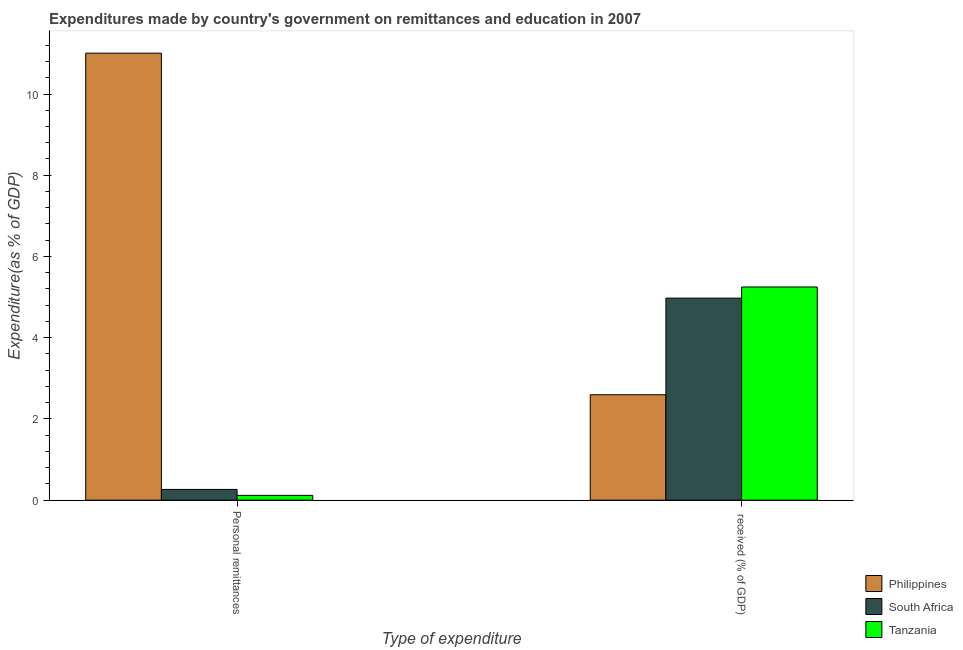How many bars are there on the 1st tick from the left?
Make the answer very short. 3. How many bars are there on the 1st tick from the right?
Offer a terse response. 3. What is the label of the 2nd group of bars from the left?
Give a very brief answer.  received (% of GDP). What is the expenditure in personal remittances in Tanzania?
Offer a very short reply. 0.12. Across all countries, what is the maximum expenditure in education?
Offer a terse response. 5.25. Across all countries, what is the minimum expenditure in education?
Provide a succinct answer. 2.6. In which country was the expenditure in personal remittances minimum?
Keep it short and to the point. Tanzania. What is the total expenditure in education in the graph?
Your answer should be compact. 12.82. What is the difference between the expenditure in personal remittances in Philippines and that in Tanzania?
Your response must be concise. 10.89. What is the difference between the expenditure in personal remittances in Philippines and the expenditure in education in South Africa?
Your answer should be compact. 6.03. What is the average expenditure in personal remittances per country?
Give a very brief answer. 3.8. What is the difference between the expenditure in education and expenditure in personal remittances in Tanzania?
Give a very brief answer. 5.13. In how many countries, is the expenditure in personal remittances greater than 1.6 %?
Make the answer very short. 1. What is the ratio of the expenditure in education in Philippines to that in South Africa?
Offer a very short reply. 0.52. In how many countries, is the expenditure in education greater than the average expenditure in education taken over all countries?
Give a very brief answer. 2. What does the 3rd bar from the left in  received (% of GDP) represents?
Make the answer very short. Tanzania. What does the 2nd bar from the right in  received (% of GDP) represents?
Give a very brief answer. South Africa. Are all the bars in the graph horizontal?
Offer a terse response. No. How many countries are there in the graph?
Offer a very short reply. 3. Are the values on the major ticks of Y-axis written in scientific E-notation?
Ensure brevity in your answer.  No. Does the graph contain any zero values?
Offer a very short reply. No. Does the graph contain grids?
Provide a short and direct response. No. Where does the legend appear in the graph?
Make the answer very short. Bottom right. How are the legend labels stacked?
Ensure brevity in your answer.  Vertical. What is the title of the graph?
Your answer should be very brief. Expenditures made by country's government on remittances and education in 2007. What is the label or title of the X-axis?
Offer a terse response. Type of expenditure. What is the label or title of the Y-axis?
Provide a short and direct response. Expenditure(as % of GDP). What is the Expenditure(as % of GDP) in Philippines in Personal remittances?
Keep it short and to the point. 11.01. What is the Expenditure(as % of GDP) of South Africa in Personal remittances?
Offer a very short reply. 0.26. What is the Expenditure(as % of GDP) of Tanzania in Personal remittances?
Your answer should be very brief. 0.12. What is the Expenditure(as % of GDP) of Philippines in  received (% of GDP)?
Provide a succinct answer. 2.6. What is the Expenditure(as % of GDP) in South Africa in  received (% of GDP)?
Your answer should be very brief. 4.97. What is the Expenditure(as % of GDP) of Tanzania in  received (% of GDP)?
Give a very brief answer. 5.25. Across all Type of expenditure, what is the maximum Expenditure(as % of GDP) of Philippines?
Offer a terse response. 11.01. Across all Type of expenditure, what is the maximum Expenditure(as % of GDP) of South Africa?
Make the answer very short. 4.97. Across all Type of expenditure, what is the maximum Expenditure(as % of GDP) in Tanzania?
Offer a very short reply. 5.25. Across all Type of expenditure, what is the minimum Expenditure(as % of GDP) in Philippines?
Give a very brief answer. 2.6. Across all Type of expenditure, what is the minimum Expenditure(as % of GDP) of South Africa?
Provide a succinct answer. 0.26. Across all Type of expenditure, what is the minimum Expenditure(as % of GDP) in Tanzania?
Your response must be concise. 0.12. What is the total Expenditure(as % of GDP) in Philippines in the graph?
Give a very brief answer. 13.6. What is the total Expenditure(as % of GDP) in South Africa in the graph?
Offer a very short reply. 5.24. What is the total Expenditure(as % of GDP) in Tanzania in the graph?
Ensure brevity in your answer.  5.37. What is the difference between the Expenditure(as % of GDP) in Philippines in Personal remittances and that in  received (% of GDP)?
Provide a short and direct response. 8.41. What is the difference between the Expenditure(as % of GDP) of South Africa in Personal remittances and that in  received (% of GDP)?
Your answer should be compact. -4.71. What is the difference between the Expenditure(as % of GDP) in Tanzania in Personal remittances and that in  received (% of GDP)?
Make the answer very short. -5.13. What is the difference between the Expenditure(as % of GDP) in Philippines in Personal remittances and the Expenditure(as % of GDP) in South Africa in  received (% of GDP)?
Your answer should be compact. 6.03. What is the difference between the Expenditure(as % of GDP) of Philippines in Personal remittances and the Expenditure(as % of GDP) of Tanzania in  received (% of GDP)?
Provide a short and direct response. 5.76. What is the difference between the Expenditure(as % of GDP) in South Africa in Personal remittances and the Expenditure(as % of GDP) in Tanzania in  received (% of GDP)?
Provide a succinct answer. -4.98. What is the average Expenditure(as % of GDP) of Philippines per Type of expenditure?
Offer a terse response. 6.8. What is the average Expenditure(as % of GDP) of South Africa per Type of expenditure?
Offer a very short reply. 2.62. What is the average Expenditure(as % of GDP) of Tanzania per Type of expenditure?
Make the answer very short. 2.68. What is the difference between the Expenditure(as % of GDP) in Philippines and Expenditure(as % of GDP) in South Africa in Personal remittances?
Ensure brevity in your answer.  10.74. What is the difference between the Expenditure(as % of GDP) in Philippines and Expenditure(as % of GDP) in Tanzania in Personal remittances?
Your answer should be very brief. 10.89. What is the difference between the Expenditure(as % of GDP) of South Africa and Expenditure(as % of GDP) of Tanzania in Personal remittances?
Provide a succinct answer. 0.15. What is the difference between the Expenditure(as % of GDP) of Philippines and Expenditure(as % of GDP) of South Africa in  received (% of GDP)?
Offer a very short reply. -2.38. What is the difference between the Expenditure(as % of GDP) of Philippines and Expenditure(as % of GDP) of Tanzania in  received (% of GDP)?
Keep it short and to the point. -2.65. What is the difference between the Expenditure(as % of GDP) in South Africa and Expenditure(as % of GDP) in Tanzania in  received (% of GDP)?
Your response must be concise. -0.27. What is the ratio of the Expenditure(as % of GDP) of Philippines in Personal remittances to that in  received (% of GDP)?
Offer a terse response. 4.24. What is the ratio of the Expenditure(as % of GDP) of South Africa in Personal remittances to that in  received (% of GDP)?
Offer a very short reply. 0.05. What is the ratio of the Expenditure(as % of GDP) of Tanzania in Personal remittances to that in  received (% of GDP)?
Your answer should be very brief. 0.02. What is the difference between the highest and the second highest Expenditure(as % of GDP) of Philippines?
Ensure brevity in your answer.  8.41. What is the difference between the highest and the second highest Expenditure(as % of GDP) of South Africa?
Give a very brief answer. 4.71. What is the difference between the highest and the second highest Expenditure(as % of GDP) in Tanzania?
Provide a short and direct response. 5.13. What is the difference between the highest and the lowest Expenditure(as % of GDP) in Philippines?
Your response must be concise. 8.41. What is the difference between the highest and the lowest Expenditure(as % of GDP) of South Africa?
Provide a succinct answer. 4.71. What is the difference between the highest and the lowest Expenditure(as % of GDP) in Tanzania?
Make the answer very short. 5.13. 